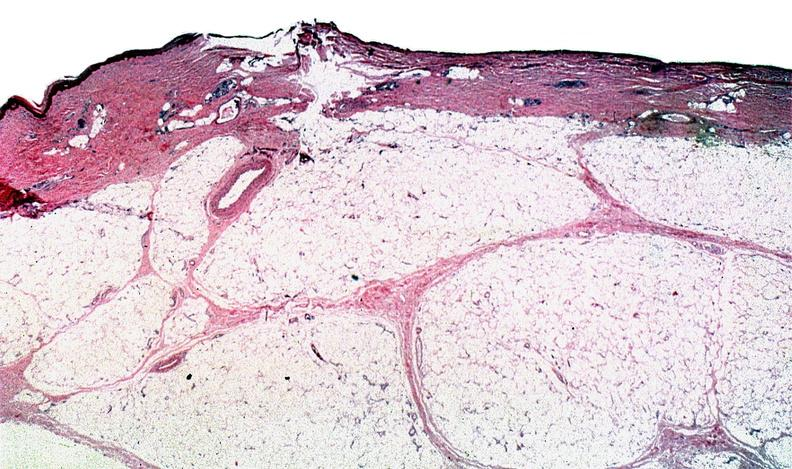does this image show thermal burned skin?
Answer the question using a single word or phrase. Yes 